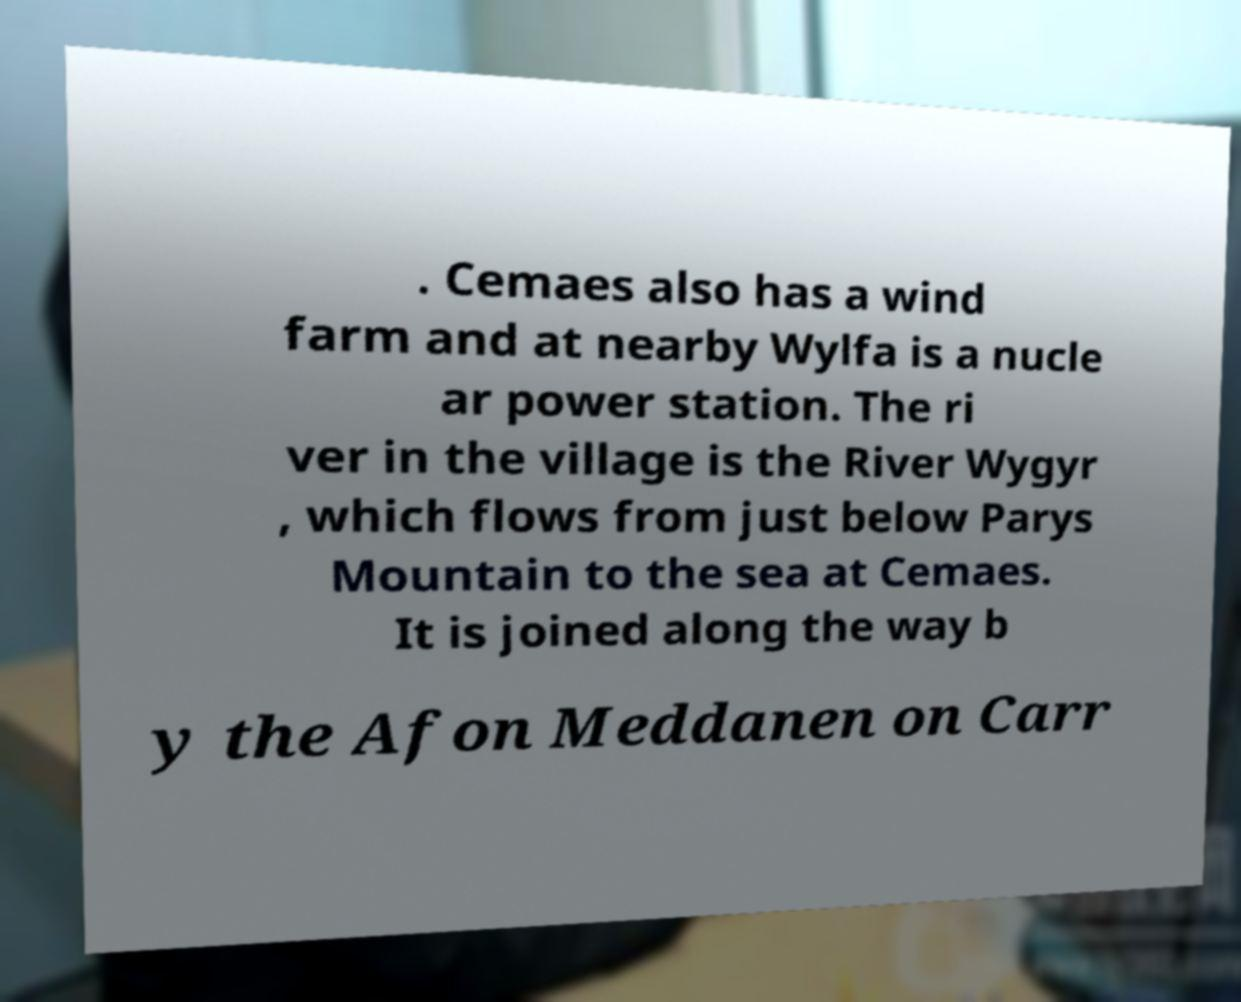What messages or text are displayed in this image? I need them in a readable, typed format. . Cemaes also has a wind farm and at nearby Wylfa is a nucle ar power station. The ri ver in the village is the River Wygyr , which flows from just below Parys Mountain to the sea at Cemaes. It is joined along the way b y the Afon Meddanen on Carr 